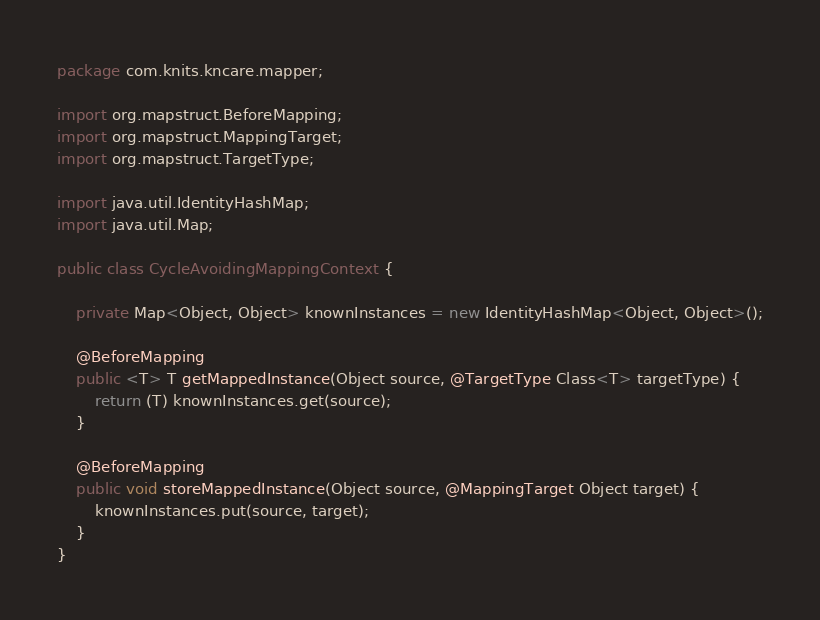Convert code to text. <code><loc_0><loc_0><loc_500><loc_500><_Java_>package com.knits.kncare.mapper;

import org.mapstruct.BeforeMapping;
import org.mapstruct.MappingTarget;
import org.mapstruct.TargetType;

import java.util.IdentityHashMap;
import java.util.Map;

public class CycleAvoidingMappingContext {

    private Map<Object, Object> knownInstances = new IdentityHashMap<Object, Object>();

    @BeforeMapping
    public <T> T getMappedInstance(Object source, @TargetType Class<T> targetType) {
        return (T) knownInstances.get(source);
    }

    @BeforeMapping
    public void storeMappedInstance(Object source, @MappingTarget Object target) {
        knownInstances.put(source, target);
    }
}
</code> 